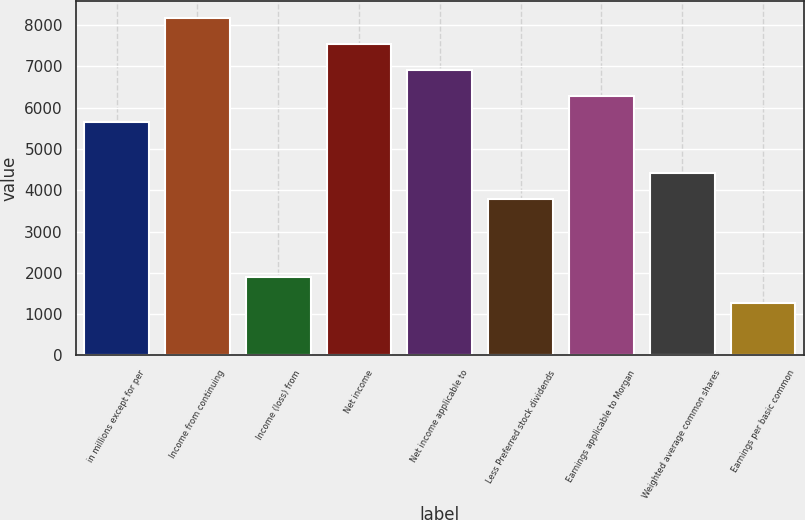<chart> <loc_0><loc_0><loc_500><loc_500><bar_chart><fcel>in millions except for per<fcel>Income from continuing<fcel>Income (loss) from<fcel>Net income<fcel>Net income applicable to<fcel>Less Preferred stock dividends<fcel>Earnings applicable to Morgan<fcel>Weighted average common shares<fcel>Earnings per basic common<nl><fcel>5665.79<fcel>8182.63<fcel>1890.53<fcel>7553.42<fcel>6924.21<fcel>3778.16<fcel>6295<fcel>4407.37<fcel>1261.32<nl></chart> 